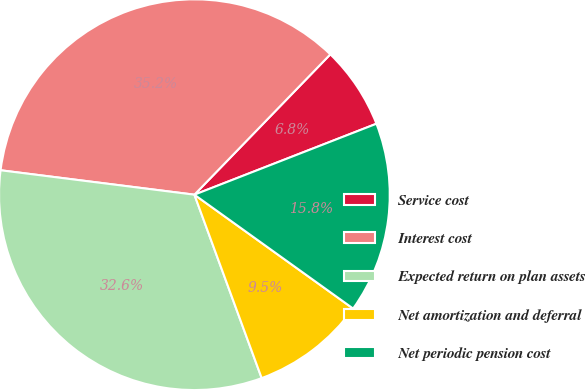Convert chart. <chart><loc_0><loc_0><loc_500><loc_500><pie_chart><fcel>Service cost<fcel>Interest cost<fcel>Expected return on plan assets<fcel>Net amortization and deferral<fcel>Net periodic pension cost<nl><fcel>6.84%<fcel>35.25%<fcel>32.59%<fcel>9.5%<fcel>15.82%<nl></chart> 